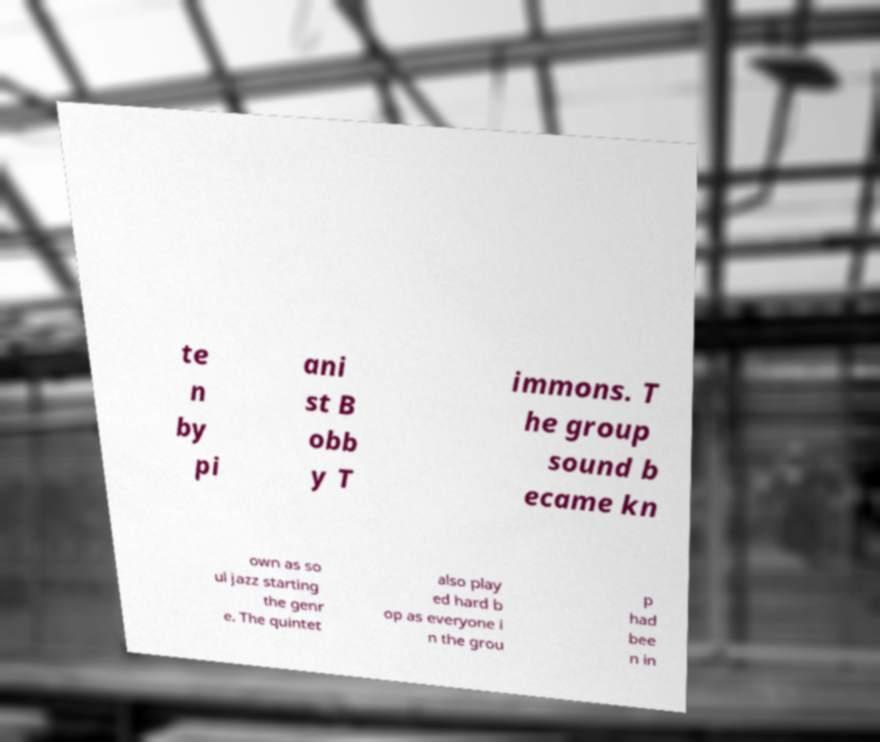What messages or text are displayed in this image? I need them in a readable, typed format. te n by pi ani st B obb y T immons. T he group sound b ecame kn own as so ul jazz starting the genr e. The quintet also play ed hard b op as everyone i n the grou p had bee n in 